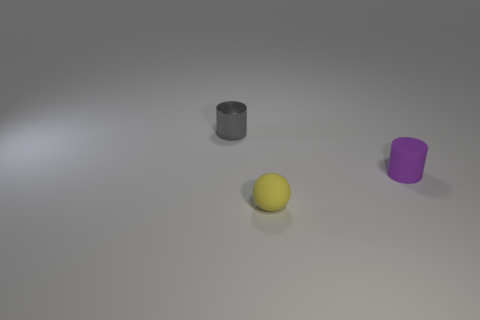Subtract 1 cylinders. How many cylinders are left? 1 Add 1 small purple cylinders. How many small purple cylinders exist? 2 Add 2 rubber cylinders. How many objects exist? 5 Subtract 0 green balls. How many objects are left? 3 Subtract all spheres. How many objects are left? 2 Subtract all yellow cylinders. Subtract all gray spheres. How many cylinders are left? 2 Subtract all gray spheres. How many purple cylinders are left? 1 Subtract all matte objects. Subtract all yellow matte blocks. How many objects are left? 1 Add 1 balls. How many balls are left? 2 